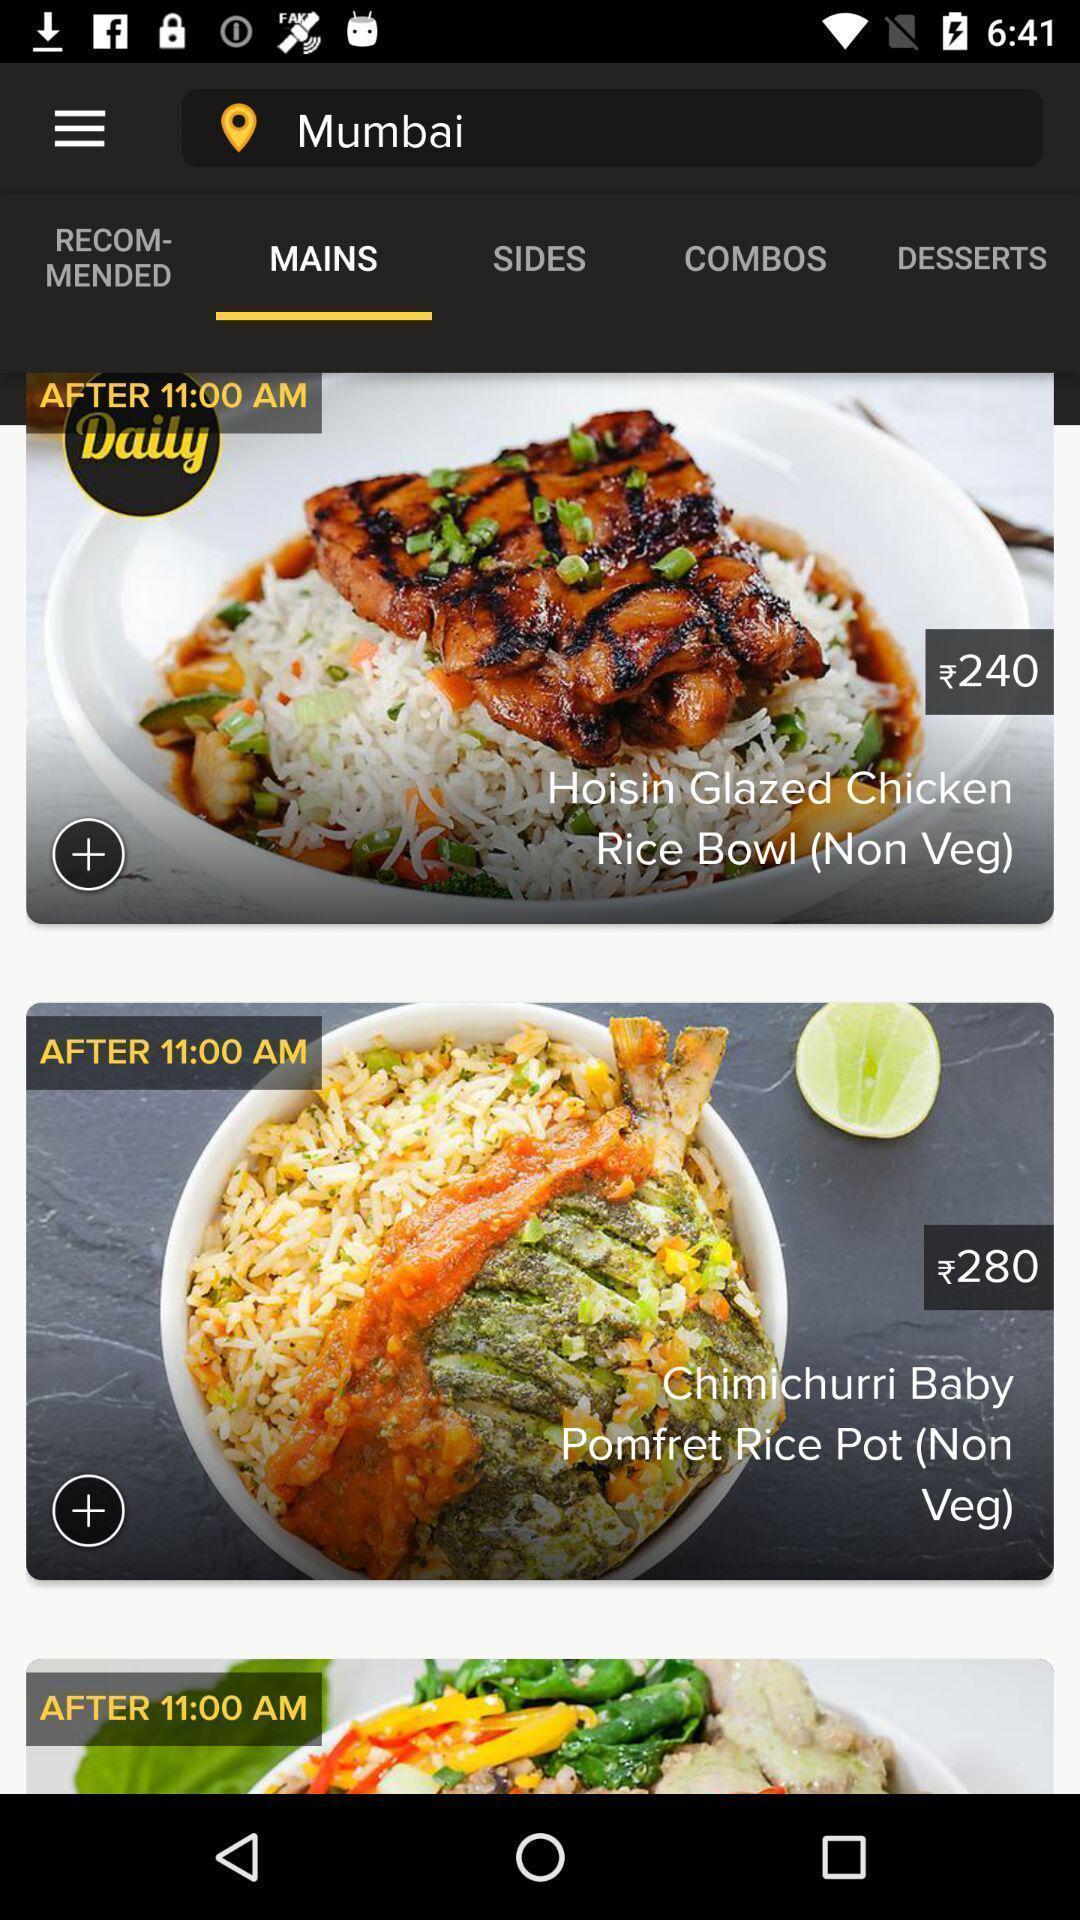What details can you identify in this image? Screen displaying about food applications. 